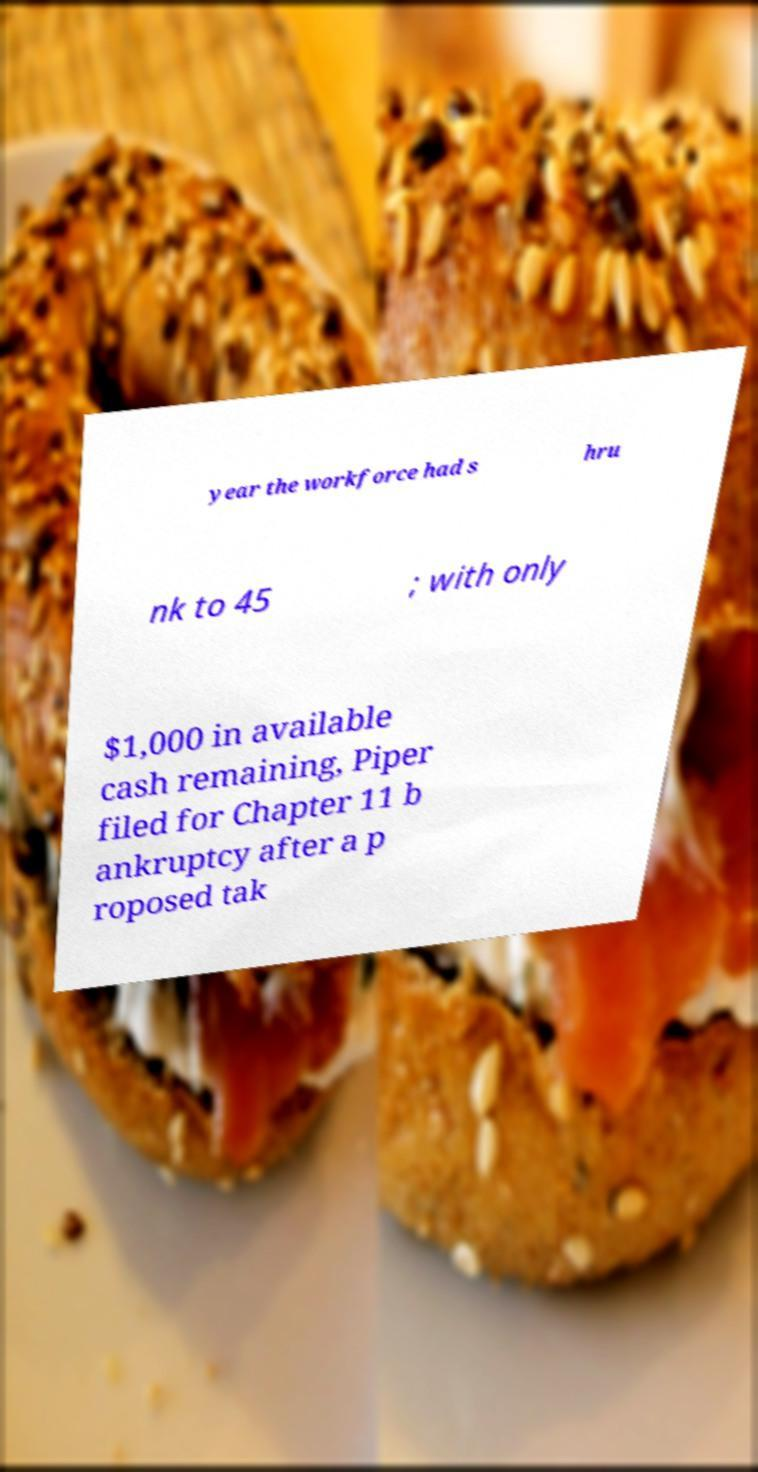Can you accurately transcribe the text from the provided image for me? year the workforce had s hru nk to 45 ; with only $1,000 in available cash remaining, Piper filed for Chapter 11 b ankruptcy after a p roposed tak 